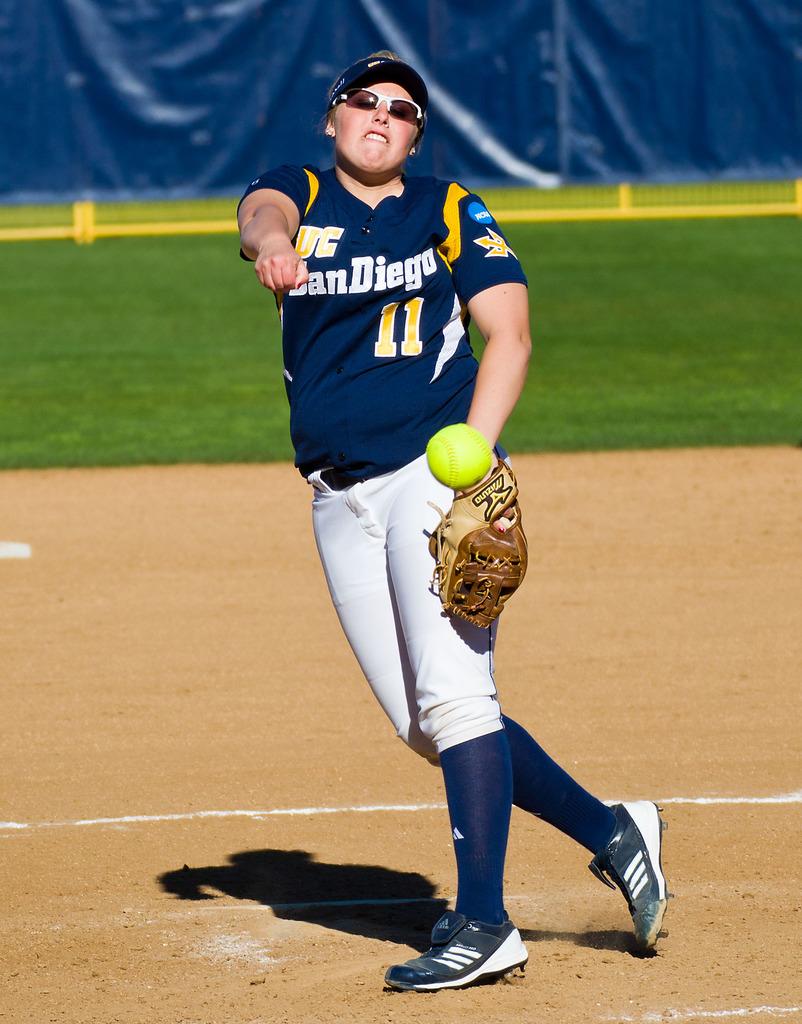What city is on the player's jersey?
Ensure brevity in your answer.  San diego. What number is on the jersey?
Your answer should be compact. 11. 